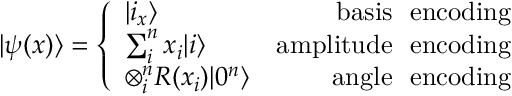<formula> <loc_0><loc_0><loc_500><loc_500>| \psi ( x ) \rangle = \left \{ \begin{array} { l r } { | i _ { x } \rangle } & { b a s i s \ e n c o d i n g } \\ { \sum _ { i } ^ { n } x _ { i } | i \rangle } & { a m p l i t u d e \ e n c o d i n g } \\ { \otimes _ { i } ^ { n } R ( x _ { i } ) | 0 ^ { n } \rangle } & { a n g l e \ e n c o d i n g } \end{array}</formula> 